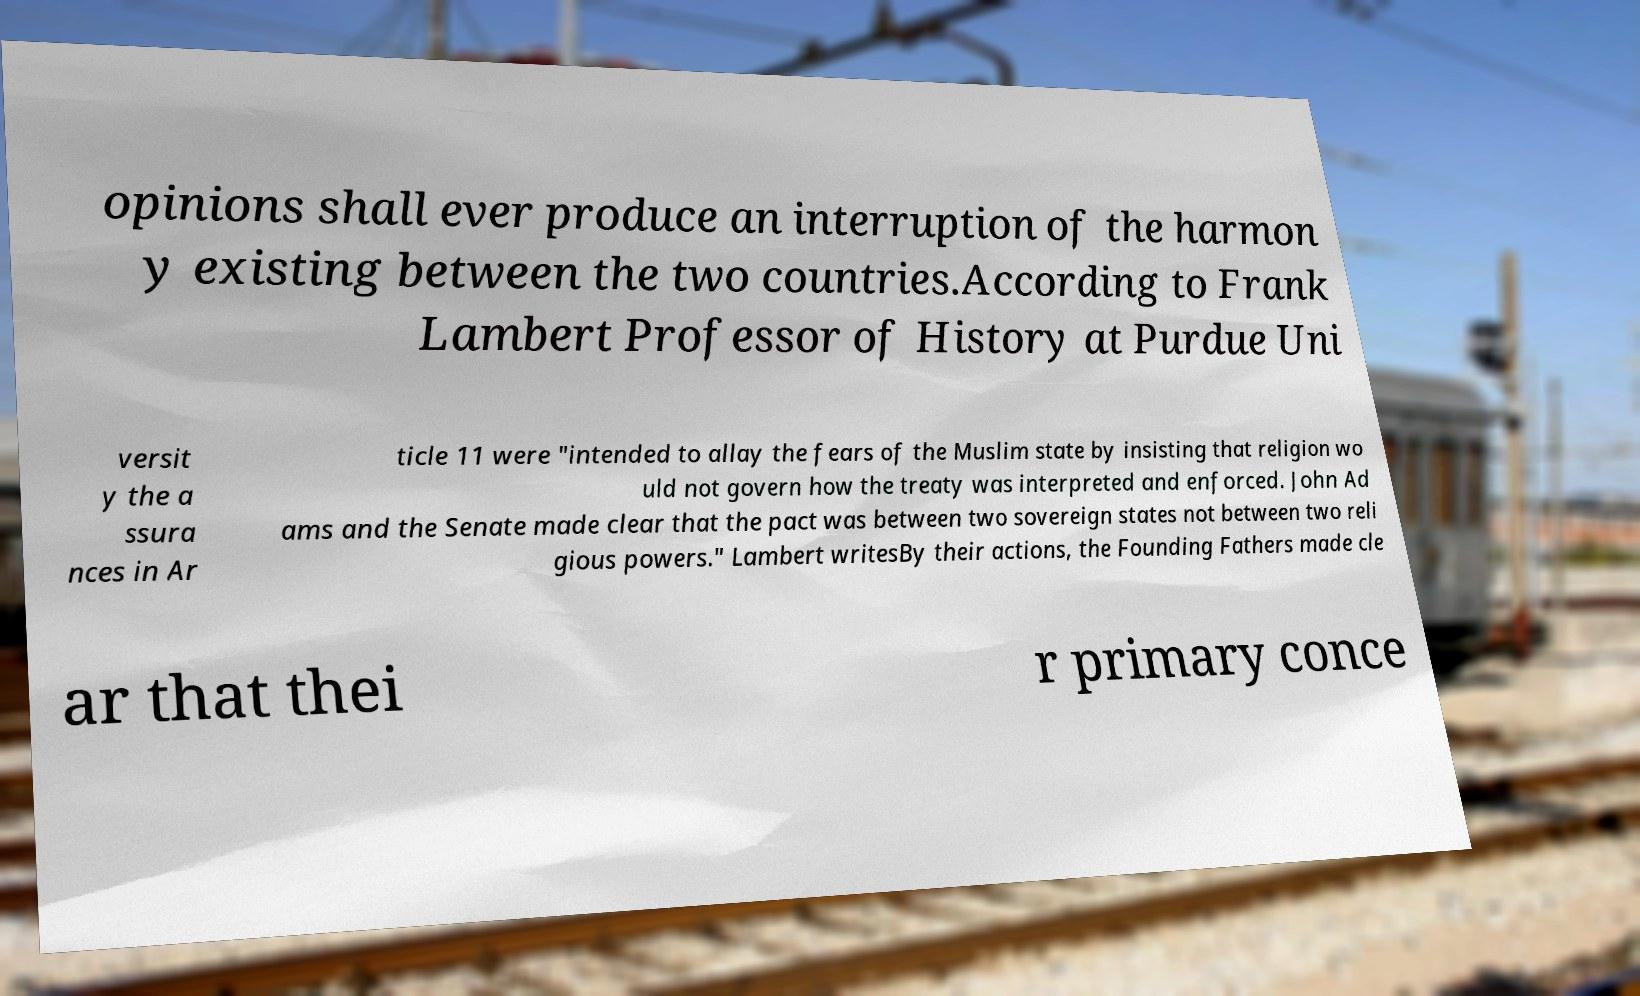Please read and relay the text visible in this image. What does it say? opinions shall ever produce an interruption of the harmon y existing between the two countries.According to Frank Lambert Professor of History at Purdue Uni versit y the a ssura nces in Ar ticle 11 were "intended to allay the fears of the Muslim state by insisting that religion wo uld not govern how the treaty was interpreted and enforced. John Ad ams and the Senate made clear that the pact was between two sovereign states not between two reli gious powers." Lambert writesBy their actions, the Founding Fathers made cle ar that thei r primary conce 